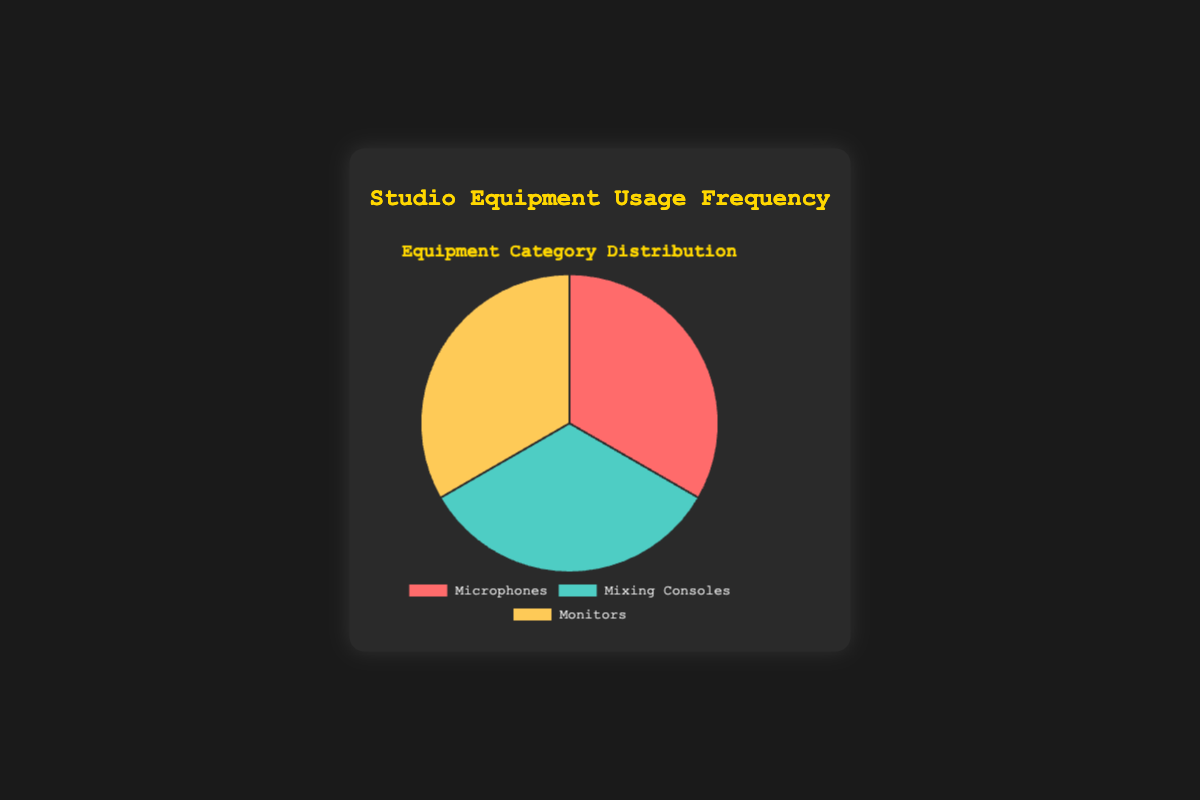Which category has the highest usage frequency? The chart shows three categories: Microphones, Mixing Consoles, and Monitors. Each category is represented by an equally sized segment in the pie chart, making it impossible to determine the highest usage frequency by visual inspection alone.
Answer: None How does the usage frequency of Mixing Consoles compare to Monitors? Visually, the three categories are represented equally, so a comparative analysis cannot be made directly from the pie chart given.
Answer: Equal If you add the usage frequencies of Microphones and Monitors, how does it compare to Mixing Consoles? The pie chart indicates equal usage frequencies of 100 for each category, summing Microphones (100) and Monitors (100), which gives 200, compared to Mixing Consoles (100).
Answer: Greater What fraction of the pie chart is represented by Microphones? The pie chart is divided into three equal segments, each representing 100 units, making each segment account for one-third of the total pie.
Answer: One-third Is the usage frequency of any one category twice as much as another? Visual inspection of the pie chart shows each category represented by an equal portion of 100 units, thus no category is twice as much as another.
Answer: No What is the combined usage frequency of all categories? Adding the usage frequencies of Microphones (100), Mixing Consoles (100), and Monitors (100), the total is 300.
Answer: 300 What visual attribute shows the category distribution? The pie chart uses color and size to represent the distribution of categories. Each category has an equally sized segment in different colors.
Answer: Color and size If Monitors usage increases by 50%, what would the new usage frequency be for Monitors? Increasing Monitors' usage by 50% of 100 results in an increase of 50 units, making the new usage frequency 100 + 50.
Answer: 150 What common visual feature do all these categories share in the chart? All categories in the pie chart share equal-sized segments, indicating they each have the same frequency value of 100.
Answer: Equal-sized segments How does the visual placement of legend labels help identify the data? The legend labels are placed at the bottom of the chart with corresponding colors, making it easy to identify each category represented in the pie chart segments.
Answer: Legend labels and colors 